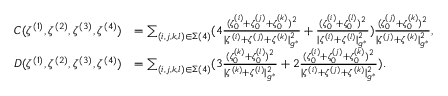<formula> <loc_0><loc_0><loc_500><loc_500>\begin{array} { r l } { C ( \zeta ^ { ( 1 ) } , \zeta ^ { ( 2 ) } , \zeta ^ { ( 3 ) } , \zeta ^ { ( 4 ) } ) } & { = \sum _ { ( i , j , k , l ) \in \Sigma ( 4 ) } ( 4 \frac { ( \zeta _ { 0 } ^ { ( i ) } + \zeta _ { 0 } ^ { ( j ) } + \zeta _ { 0 } ^ { ( k ) } ) ^ { 2 } } { | { \zeta ^ { ( i ) } } + { \zeta ^ { ( j ) } } + { \zeta ^ { ( k ) } } | _ { g ^ { * } } ^ { 2 } } + \frac { ( \zeta _ { 0 } ^ { ( i ) } + \zeta _ { 0 } ^ { ( l ) } ) ^ { 2 } } { | { \zeta ^ { ( i ) } } + { \zeta ^ { ( l ) } } | _ { g ^ { * } } ^ { 2 } } ) \frac { ( \zeta _ { 0 } ^ { ( j ) } + \zeta _ { 0 } ^ { ( k ) } ) ^ { 2 } } { | \zeta ^ { ( j ) } + \zeta ^ { ( k ) } | _ { g ^ { * } } ^ { 2 } } , } \\ { D ( \zeta ^ { ( 1 ) } , \zeta ^ { ( 2 ) } , \zeta ^ { ( 3 ) } , \zeta ^ { ( 4 ) } ) } & { = \sum _ { ( i , j , k , l ) \in \Sigma ( 4 ) } ( 3 \frac { ( \zeta _ { 0 } ^ { ( k ) } + \zeta _ { 0 } ^ { ( l ) } ) ^ { 2 } } { | { \zeta ^ { ( k ) } } + { \zeta ^ { ( l ) } } | _ { g ^ { * } } ^ { 2 } } + 2 \frac { ( \zeta _ { 0 } ^ { ( i ) } + \zeta _ { 0 } ^ { ( j ) } + \zeta _ { 0 } ^ { ( k ) } ) ^ { 2 } } { | { \zeta ^ { ( i ) } } + { \zeta ^ { ( j ) } } + { \zeta ^ { ( k ) } } | _ { g ^ { * } } ^ { 2 } } ) . } \end{array}</formula> 